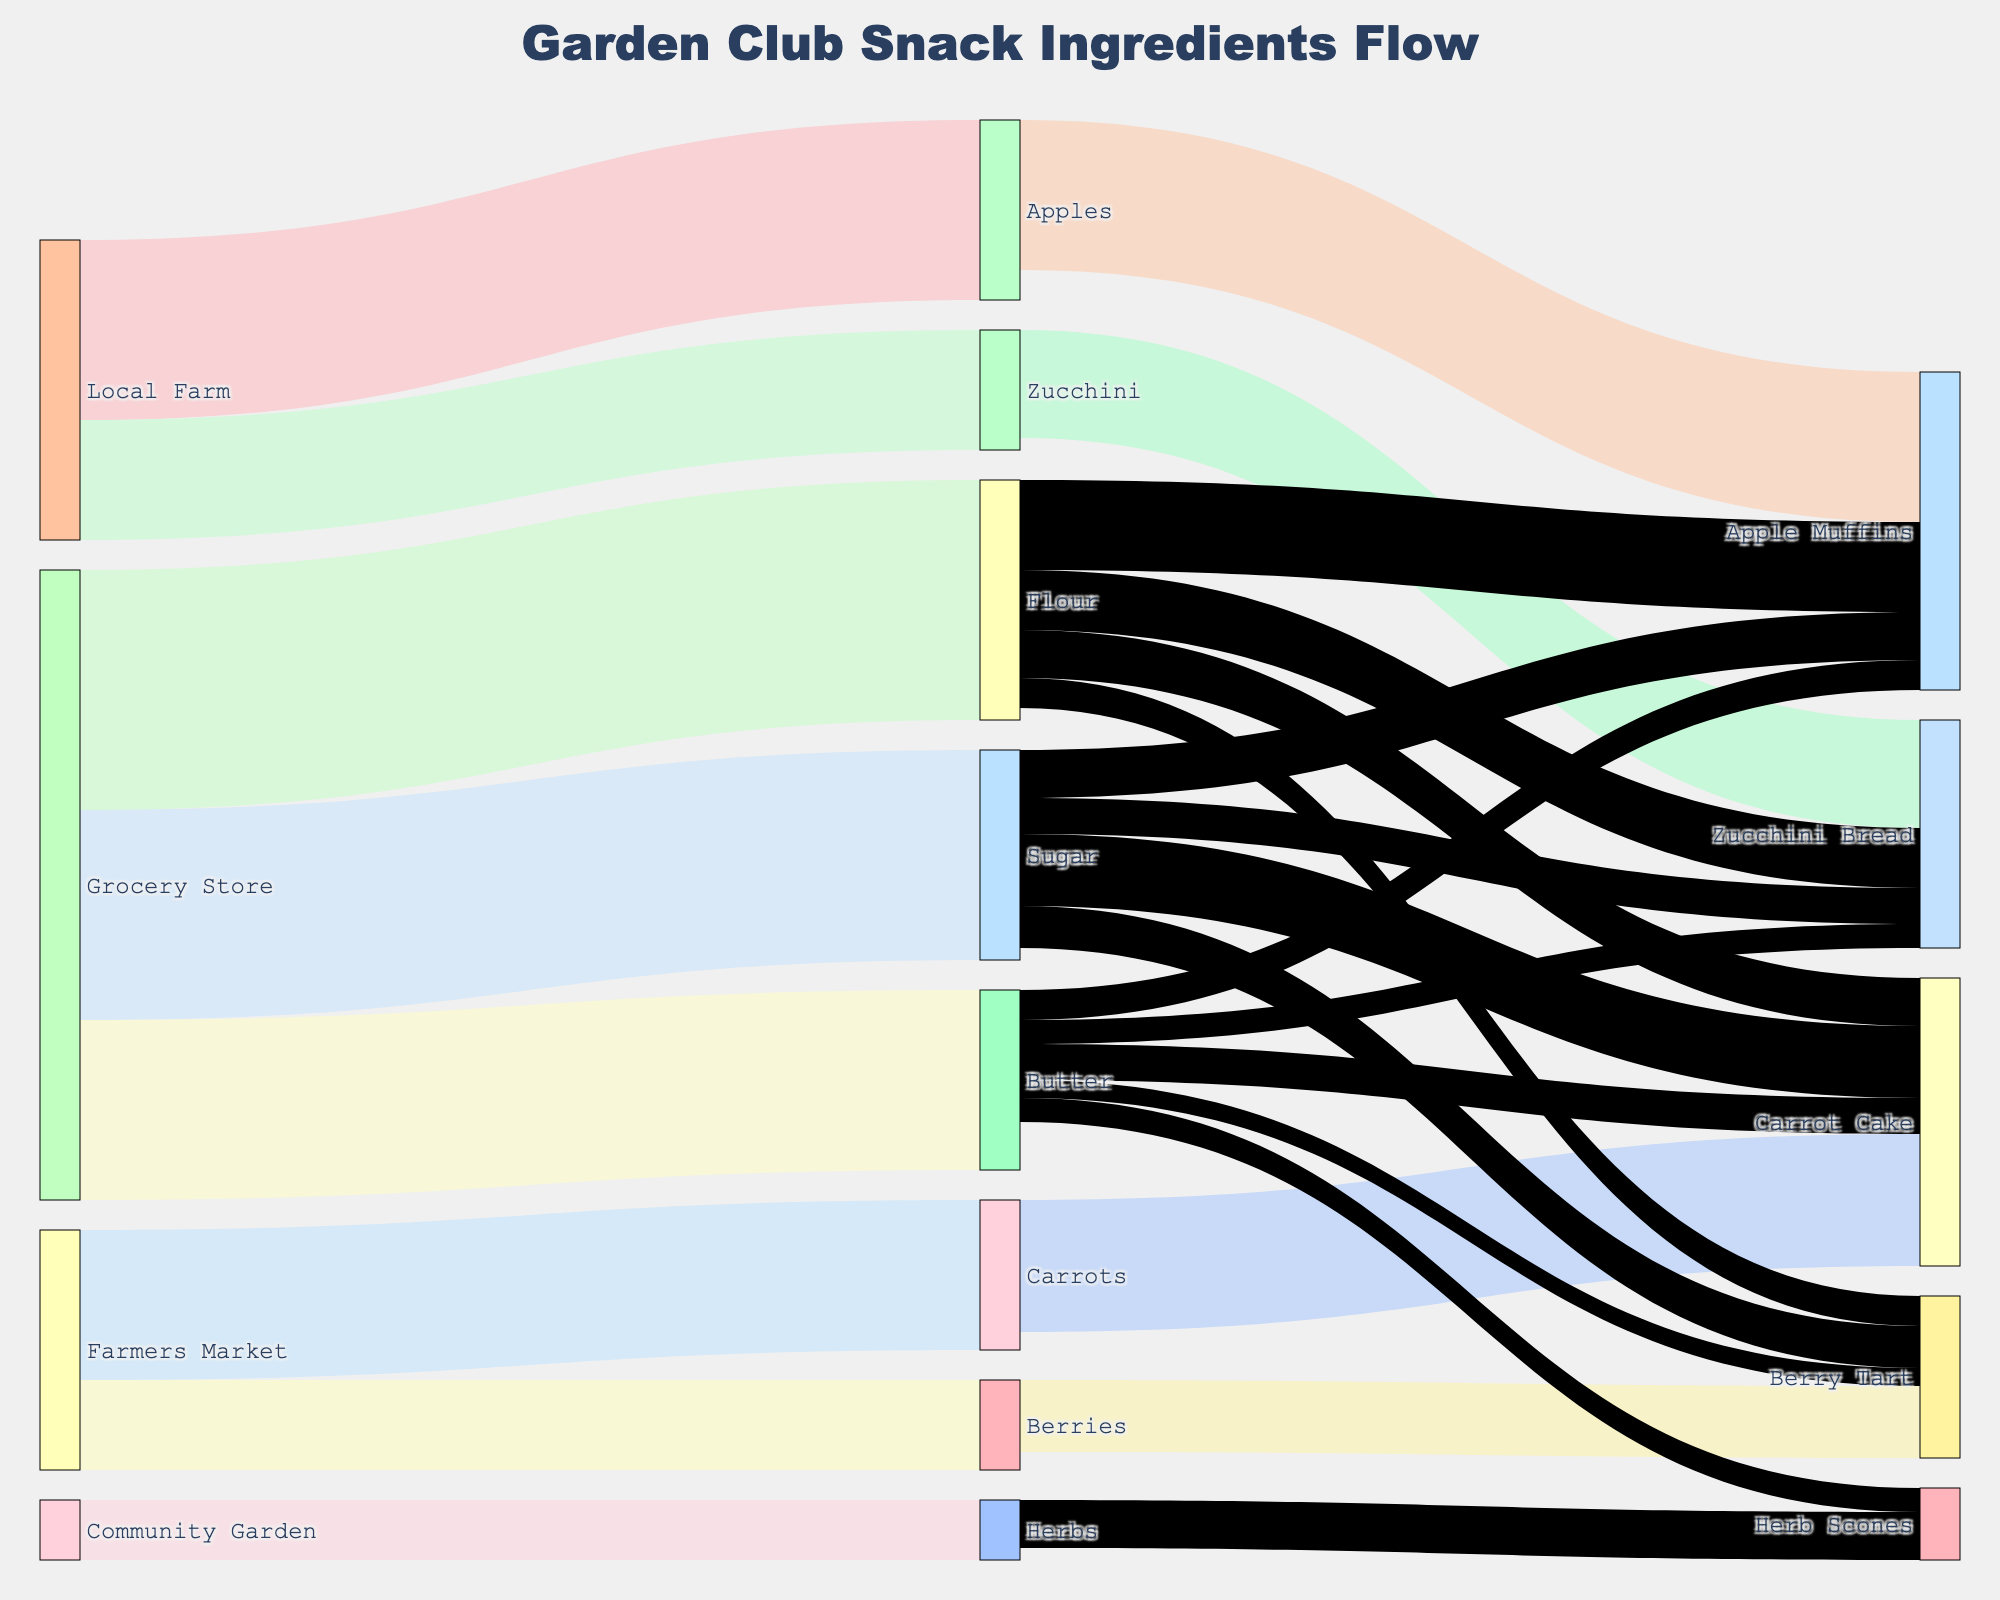How many different sources are shown in the diagram? The diagram lists sources for ingredients such as Local Farm, Farmers Market, Community Garden, and Grocery Store. Count each one to determine the total.
Answer: 4 Which ingredient has the highest flow from the Grocery Store? Look at the connections from Grocery Store to the various ingredients and compare their values. Flour has 40, Sugar has 35, and Butter has 30.
Answer: Flour What is the total quantity of Apples used in Apple Muffins? Check the flow from Apples to Apple Muffins, which shows a value of 25.
Answer: 25 Which source provides the ingredients for Herb Scones? By tracing the connections to Herb Scones, it is seen that Community Garden (Herbs) and Grocery Store (Butter) provide the ingredients.
Answer: 2 Compare the total amount of Flours and Sugars used across all final products. Which one is higher and by how much? Sum the flour values across products: 15 (Apple Muffins) + 10 (Zucchini Bread) + 8 (Carrot Cake) + 5 (Berry Tart) = 38. Do the same for sugar: 8 (Apple Muffins) + 6 (Zucchini Bread) + 12 (Carrot Cake) + 7 (Berry Tart) = 33. Compare the sums: 38 (Flour) > 33 (Sugar) by 5.
Answer: Flour by 5 Which final product gets the smallest quantity of Sugar? Check the quantities of Sugar flowing to each final product: Apple Muffins (8), Zucchini Bread (6), Carrot Cake (12), Berry Tart (7). The smallest value is for Zucchini Bread.
Answer: Zucchini Bread How many final products use ingredients from the Local Farm? Find the connections from Local Farm to final products: Apples to Apple Muffins, Zucchini to Zucchini Bread. So, count them.
Answer: 2 What is the total value of Butter used in all final products? Add up the Butter values: Apple Muffins (5), Zucchini Bread (4), Carrot Cake (6), Berry Tart (3), Herb Scones (4). The total is 5+4+6+3+4 = 22.
Answer: 22 Which final product requires inputs from the most different sources? Compare the number of sources feeding into each final product. Herbed Scones has input from Herbs (Community Garden) and Butter (Grocery Store). Apple Muffins, Zucchini Bread, and Carrot Cake have inputs from multiple sources like Flour and Sugar (Grocery Store), and specific items like Apples and Zucchini (Local Farm).
Answer: Apple Muffins What is the smallest flow value shown in the entire diagram? Review each connection and find the smallest value mentioned. The smallest flow value is between Herbs and Herb Scones, which is 8.
Answer: 8 